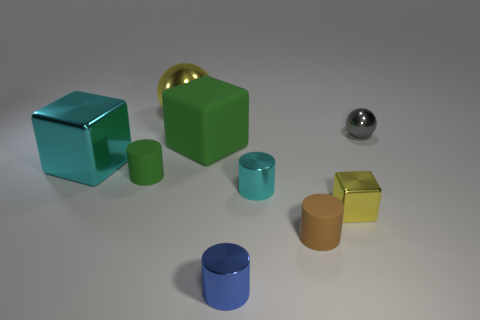There is a thing that is right of the yellow thing that is to the right of the cyan thing to the right of the blue cylinder; what is its material? metal 